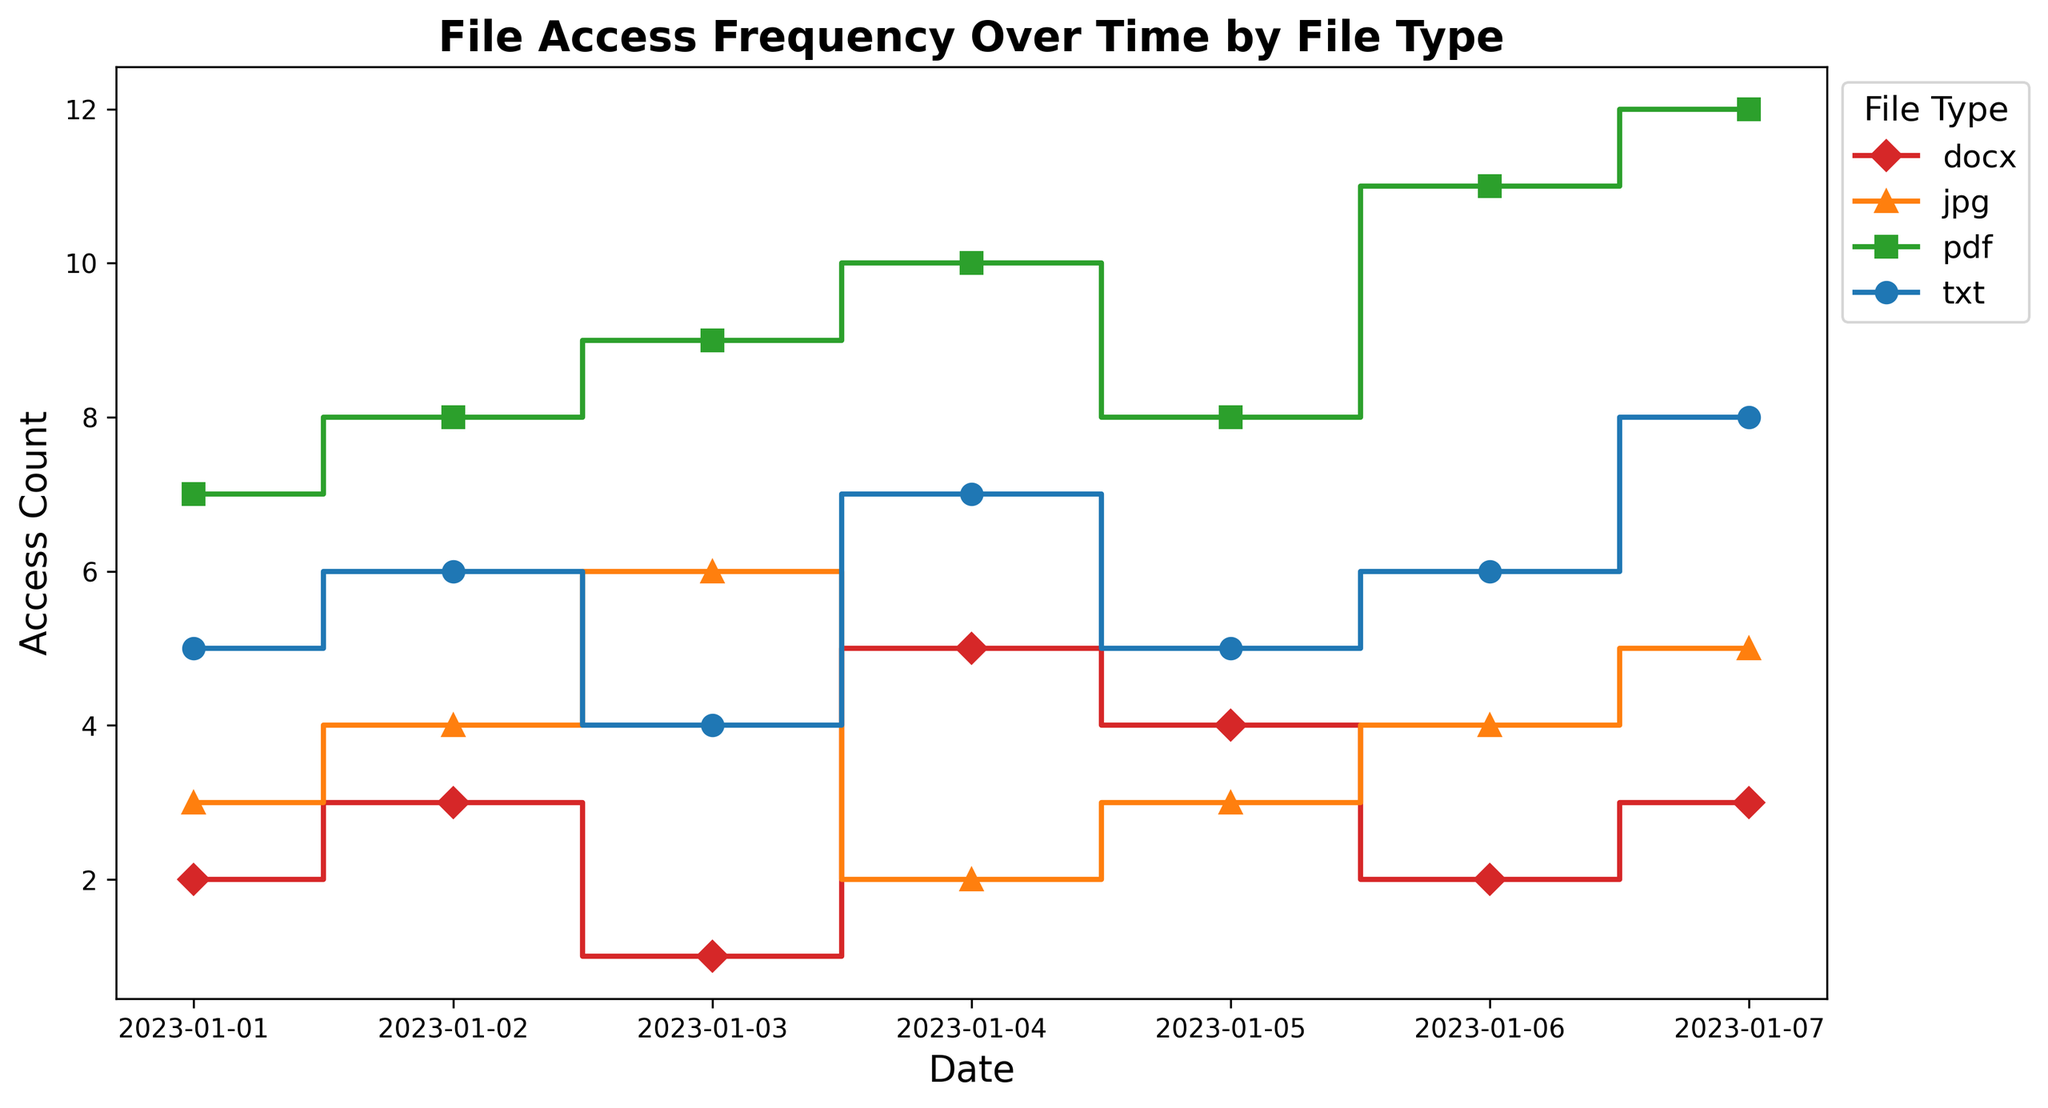What is the most frequently accessed file type on January 7? On January 7, the counts are txt: 8, jpg: 5, pdf: 12, docx: 3. The pdf file type has the highest count of 12.
Answer: pdf Which file type has the least access count on January 4? On January 4, the counts are txt: 7, jpg: 2, pdf: 10, docx: 5. The jpg file type has the lowest count of 2.
Answer: jpg Is the access count for txt files increasing or decreasing from January 1 to January 7? The access counts for txt are 5, 6, 4, 7, 5, 6, 8 across January 1 to January 7. The counts fluctuate but generally increase towards January 7, with the highest count on January 7.
Answer: Increasing What was the total access count for all file types on January 2? On January 2, the counts are txt: 6, jpg: 4, pdf: 8, docx: 3. Summing these values gives 6 + 4 + 8 + 3 = 21.
Answer: 21 Which file type experienced the greatest variability in access count over the given period? The variability for each file type can be noticed by examining the range (max - min) of their counts:
- txt: 8 - 4 = 4
- jpg: 6 - 2 = 4
- pdf: 12 - 7 = 5
- docx: 5 - 1 = 4
The pdf file type varied the most with a range of 5.
Answer: pdf How many times did the access count for jpg files increase compared to the previous day? Examining the counts for jpg:
- Jan 2: 4 (increased from Jan 1: 3)
- Jan 3: 6 (increased from Jan 2: 4)
- Jan 4: 2 (decreased from Jan 3: 6)
- Jan 5: 3 (increased from Jan 4: 2)
- Jan 6: 4 (increased from Jan 5: 3)
- Jan 7: 5 (increased from Jan 6: 4)
There are 5 days when the access count for jpg files increased relative to the previous day: Jan 2, Jan 3, Jan 5, Jan 6, and Jan 7.
Answer: 5 What is the average access count for pdf files over the period? The counts for pdf are 7, 8, 9, 10, 8, 11, 12. Summing them gives 65. There are 7 days, so the average is 65 / 7 ≈ 9.29.
Answer: 9.29 By how many access counts does the most accessed file type on January 5 exceed the least accessed file type on the same day? On January 5, the counts are txt: 5, jpg: 3, pdf: 8, docx: 4. The most accessed file type is pdf with 8, and the least is jpg with 3. The difference is 8 - 3 = 5.
Answer: 5 Which day had the highest total file access count? Adding up access counts for each day:
- Jan 1: 5 + 3 + 7 + 2 = 17
- Jan 2: 6 + 4 + 8 + 3 = 21
- Jan 3: 4 + 6 + 9 + 1 = 20
- Jan 4: 7 + 2 + 10 + 5 = 24
- Jan 5: 5 + 3 + 8 + 4 = 20
- Jan 6: 6 + 4 + 11 + 2 = 23
- Jan 7: 8 + 5 + 12 + 3 = 28
The highest total access count is on January 7, with 28 accesses.
Answer: January 7 